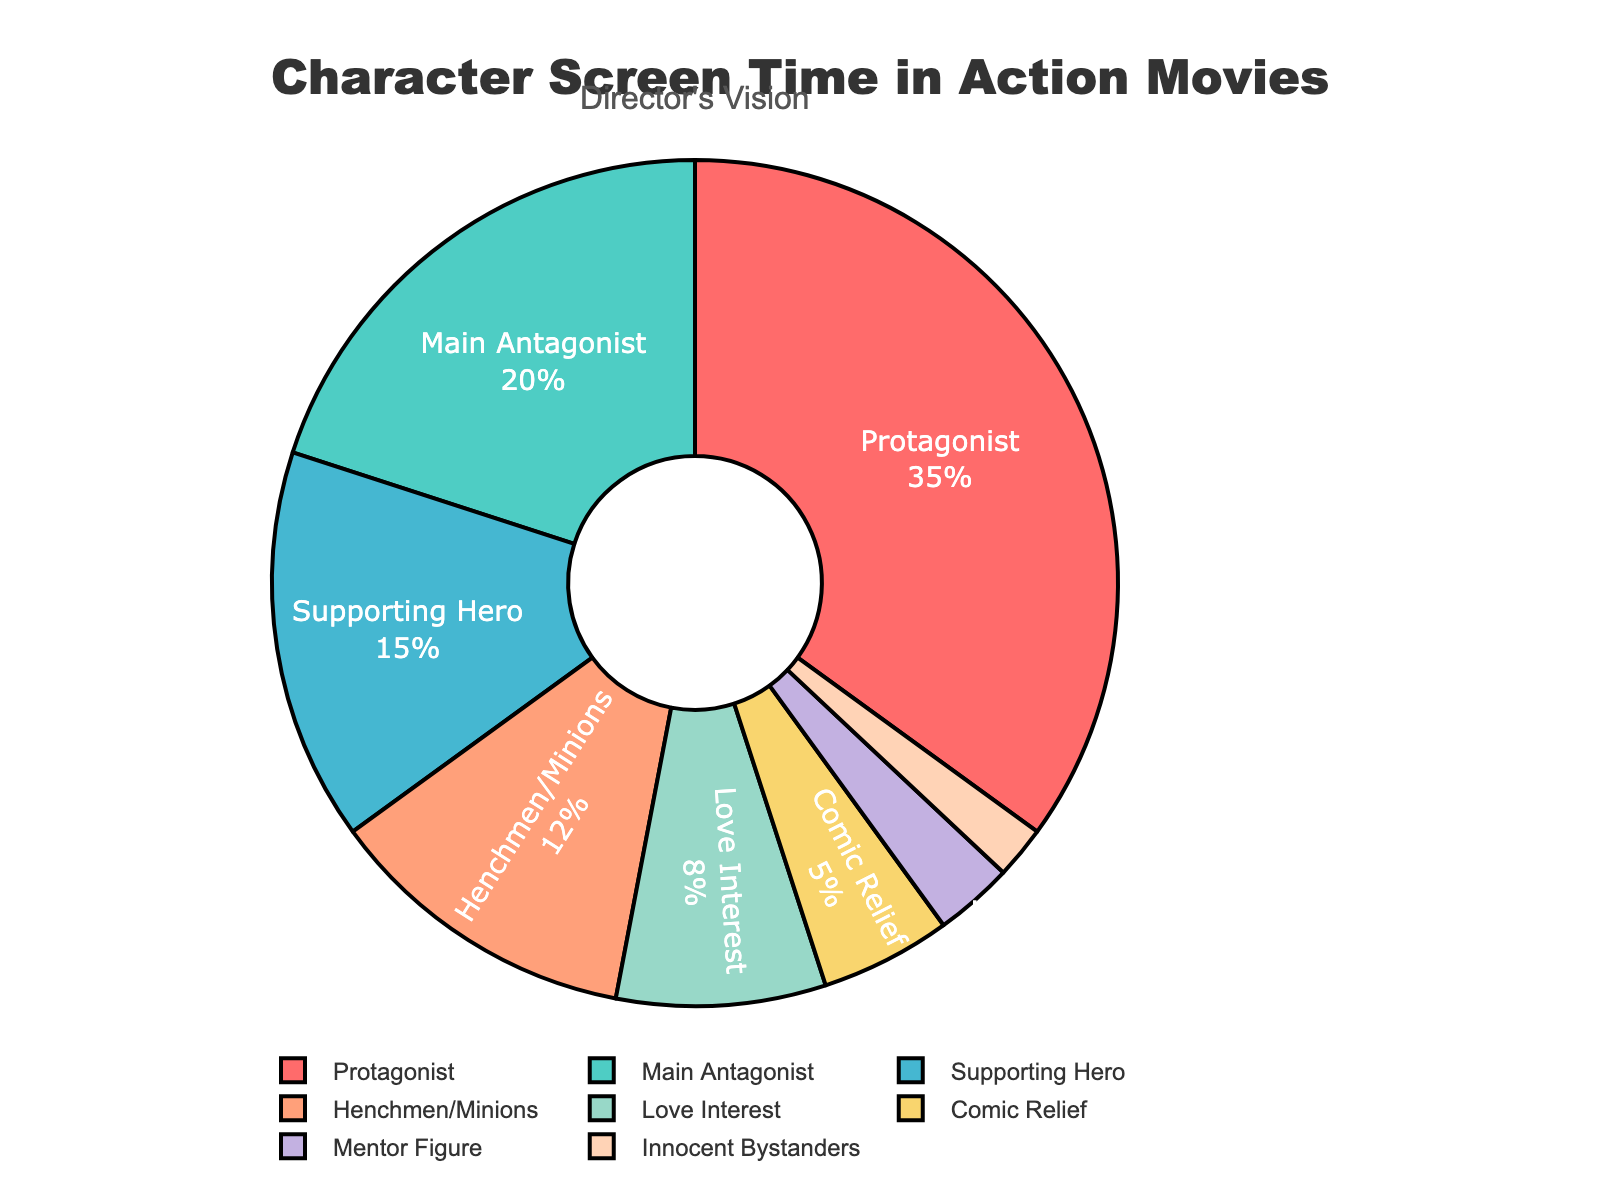What is the sum of the screen time percentage of the Protagonist and Supporting Hero? The percentage of screen time for the Protagonist is 35% and for the Supporting Hero is 15%. The sum is 35 + 15.
Answer: 50% Which character type has the least screen time? By comparing all the percentages, Innocent Bystanders have the lowest percentage at 2%.
Answer: Innocent Bystanders What is the difference in screen time percentage between the Main Antagonist and Henchmen/Minions? The percentage for the Main Antagonist is 20% and for Henchmen/Minions is 12%. The difference is 20 - 12.
Answer: 8% Can you identify which character types together make up more than 50% of the screen time? The Protagonist (35%) and the Main Antagonist (20%) together make up 35 + 20 = 55%, which is more than 50%.
Answer: Protagonist and Main Antagonist Which segment is represented with the color red? The color red corresponds to the segment for the Protagonist.
Answer: Protagonist How many character types have a screen time percentage below 10%? The character types with screen time percentages below 10% are Love Interest (8%), Comic Relief (5%), Mentor Figure (3%), and Innocent Bystanders (2%). In total, there are 4 character types.
Answer: 4 Is the percentage of screen time for the Henchmen/Minions greater than the total percentage of Mentor Figure, Comic Relief, and Innocent Bystanders combined? The percentage for Henchmen/Minions is 12%. The total percentage for Mentor Figure (3%), Comic Relief (5%), and Innocent Bystanders (2%) is 3 + 5 + 2 = 10%. 12% is greater than 10%.
Answer: Yes What percentage of the screen time is not allocated to Protagonist, Main Antagonist, and Supporting Hero? The combined screen time percentage for Protagonist (35%), Main Antagonist (20%), and Supporting Hero (15%) is 35 + 20 + 15 = 70%. The percentage not allocated to these types is 100 - 70.
Answer: 30% Which two character types have the closest screen time percentages? Love Interest (8%) and Comic Relief (5%) have the closest percentages with a difference of 3%.
Answer: Love Interest and Comic Relief What is the visual proportion of the screen time allocated to Mentor Figure compared to the Protagonist? The screen time percentage for Mentor Figure is 3%, while it's 35% for the Protagonist. So, Mentor Figure's screen time proportion compared to the Protagonist is 3 / 35.
Answer: 3/35 